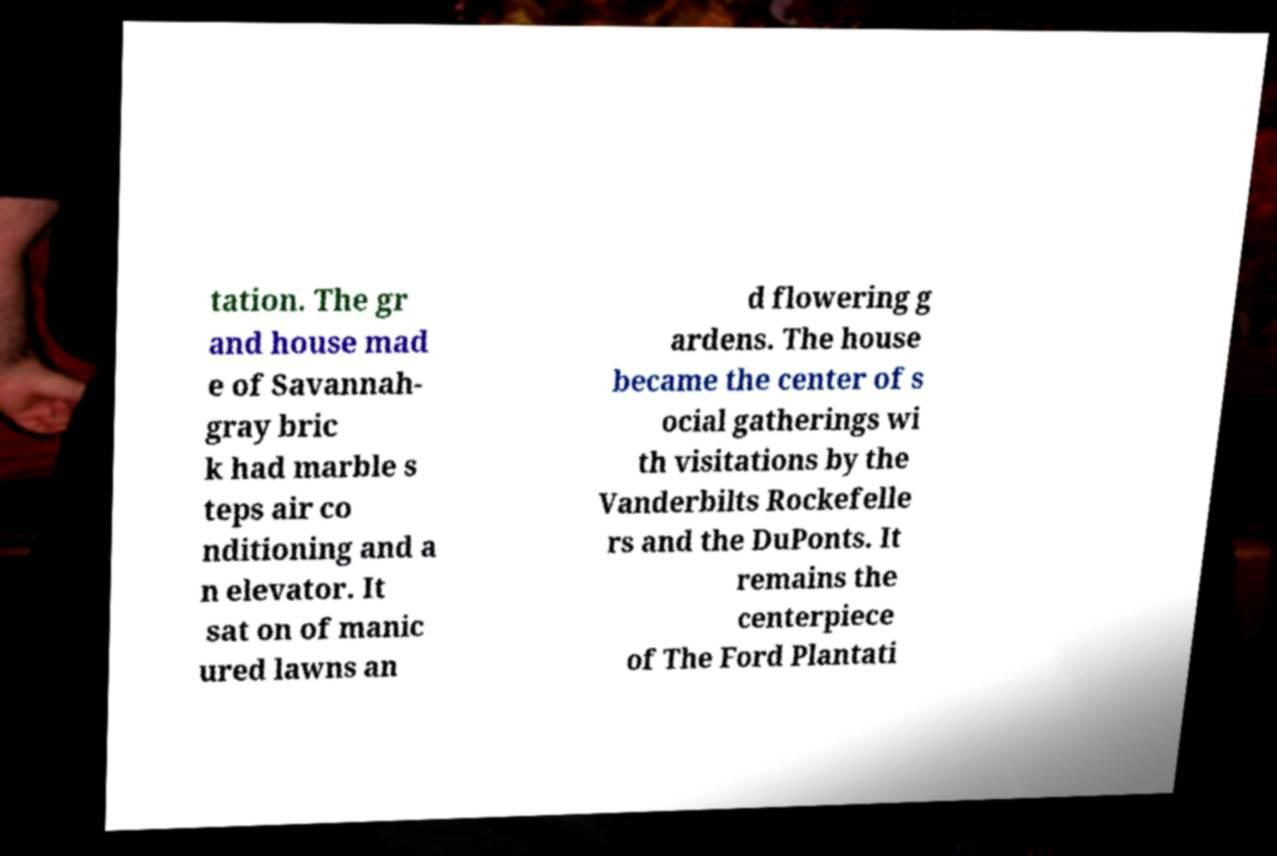Can you read and provide the text displayed in the image?This photo seems to have some interesting text. Can you extract and type it out for me? tation. The gr and house mad e of Savannah- gray bric k had marble s teps air co nditioning and a n elevator. It sat on of manic ured lawns an d flowering g ardens. The house became the center of s ocial gatherings wi th visitations by the Vanderbilts Rockefelle rs and the DuPonts. It remains the centerpiece of The Ford Plantati 